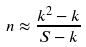Convert formula to latex. <formula><loc_0><loc_0><loc_500><loc_500>n \approx \frac { k ^ { 2 } - k } { S - k }</formula> 